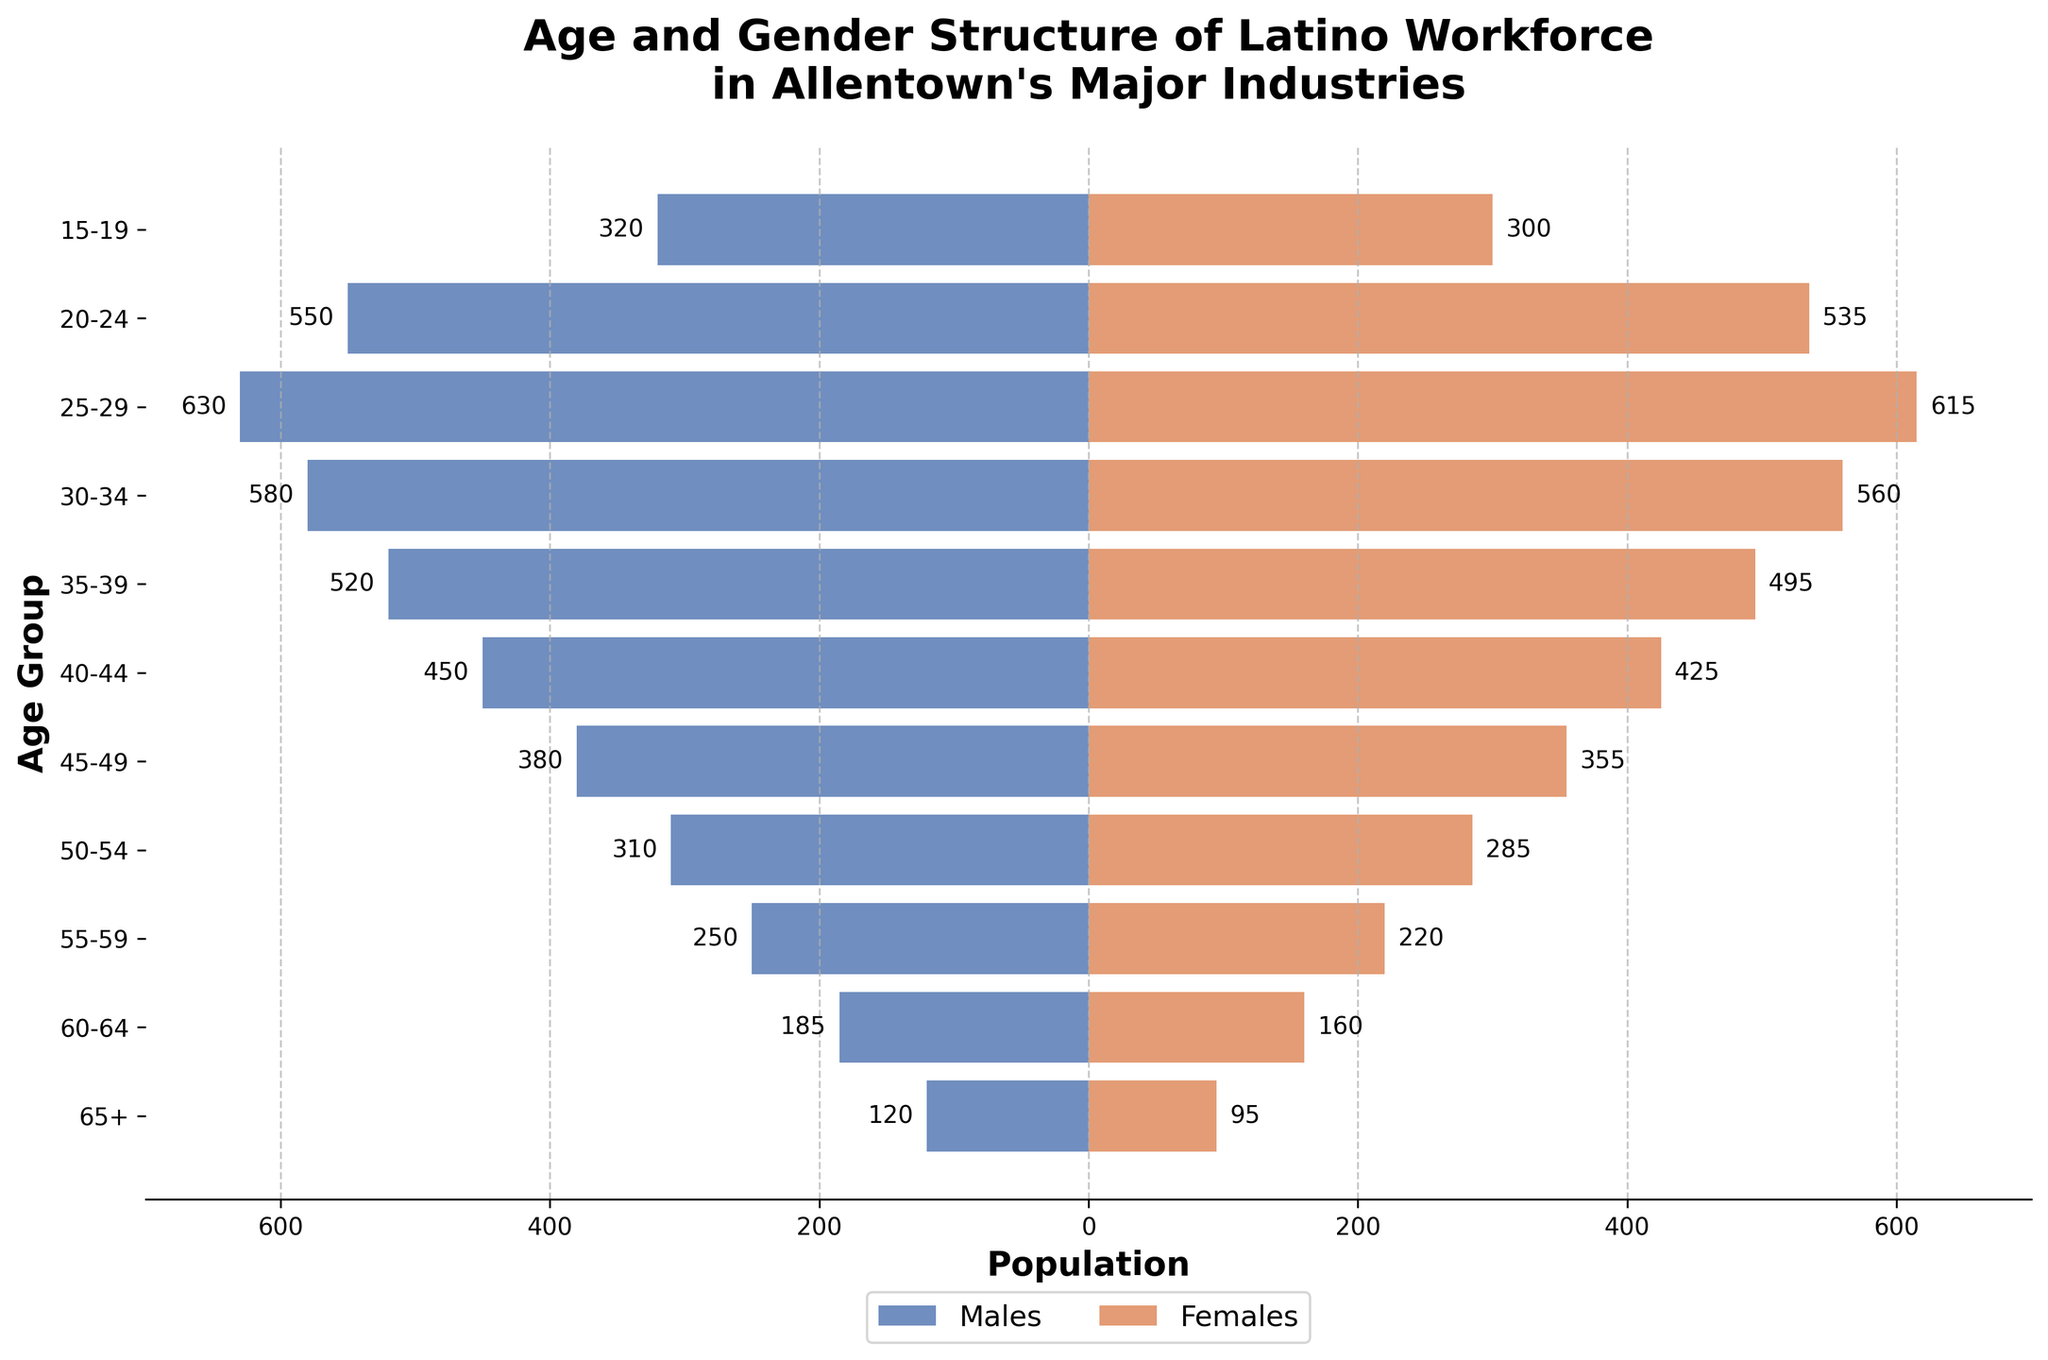What is the title of the figure? The title is displayed at the top of the figure, centered and in bold text. It reads "Age and Gender Structure of Latino Workforce in Allentown's Major Industries".
Answer: Age and Gender Structure of Latino Workforce in Allentown's Major Industries Which age group has the highest number of males in the workforce? By comparing the lengths of the blue bars (representing males) across all age groups, the 25-29 age group has the longest bar indicating the highest number of males.
Answer: 25-29 How many females are in the 30-34 age group? The orange bar corresponding to the 30-34 age group represents females. Reading the number next to it, we see the value is 560.
Answer: 560 What is the total number of people (males and females) in the 45-49 age group? First, find the number of males (380) and females (355) from the bars in the 45-49 age group. Sum these numbers: 380 + 355.
Answer: 735 Which gender has more individuals in the 15-19 age group, and by how much? Compare the blue bar (males) and the orange bar (females) for the 15-19 age group. Males have 320 and females have 300. Subtract the smaller number from the larger number: 320 - 300.
Answer: Males, by 20 In which age group is the gender distribution closest to being equal? Examine the bars for each age group and identify which pair of bars (one blue and one orange) are closest in length. The 40-44 age group has males at 450 and females at 425, the smallest difference (450-425) is 25.
Answer: 40-44 What is the difference in the number of males between the 20-24 and 60-64 age groups? Identify the number of males in the 20-24 age group (550) and the 60-64 age group (185). Subtract the smaller number from the larger number: 550 - 185.
Answer: 365 Across all age groups, which has the lowest number of females? Find the shortest orange bar size across all age groups. It appears that the 65+ age group has the shortest bar representing females with a value of 95.
Answer: 65+ What is the combined number of males and females in the 50-54 and 55-59 age groups? Sum the males and females for both age groups individually and then together: (310 males + 285 females) + (250 males + 220 females) = 595 + 470.
Answer: 1065 